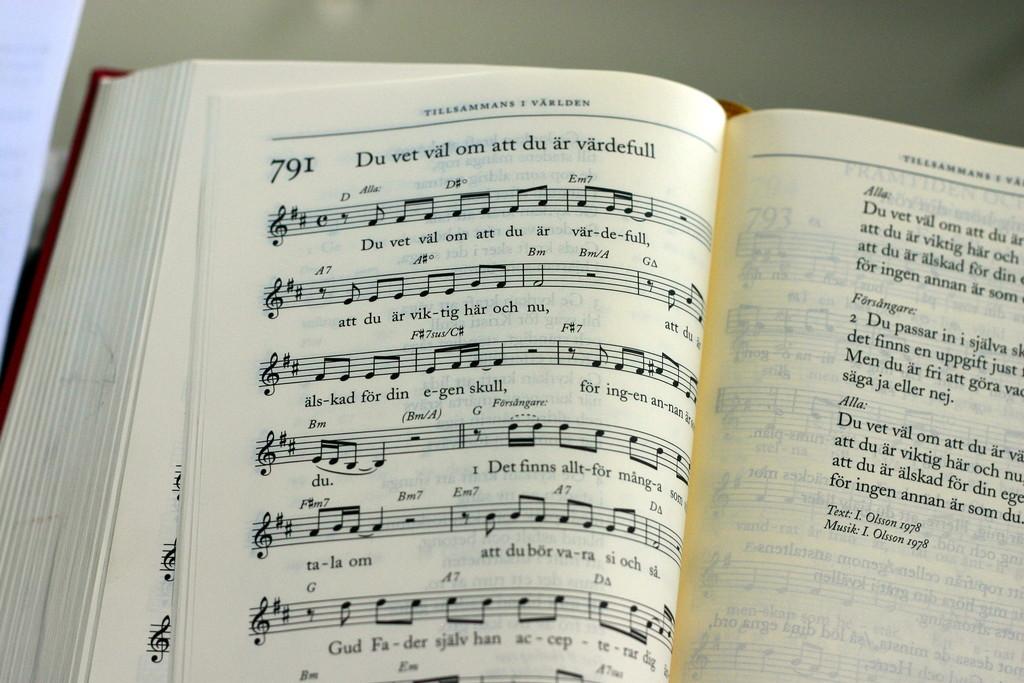What is the name of this song?
Keep it short and to the point. Du vet val om att du ar vardefull. What number is wrote beside du?
Your response must be concise. 791. 